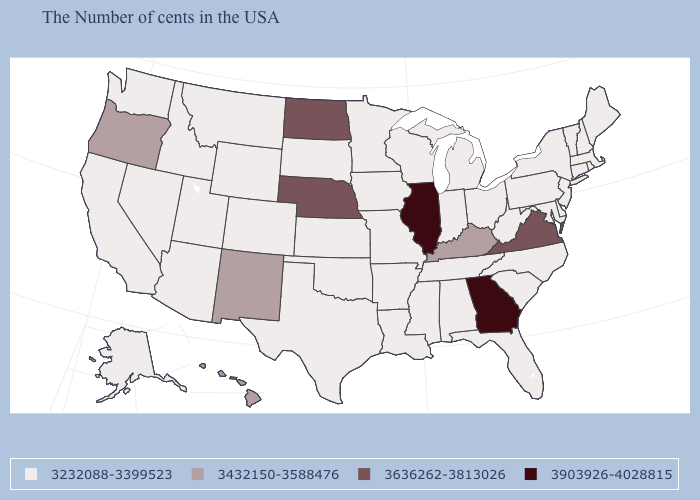Name the states that have a value in the range 3432150-3588476?
Answer briefly. Kentucky, New Mexico, Oregon, Hawaii. What is the value of Iowa?
Concise answer only. 3232088-3399523. Among the states that border Ohio , does Kentucky have the highest value?
Write a very short answer. Yes. What is the value of New Jersey?
Quick response, please. 3232088-3399523. Name the states that have a value in the range 3636262-3813026?
Keep it brief. Virginia, Nebraska, North Dakota. What is the highest value in the USA?
Give a very brief answer. 3903926-4028815. Name the states that have a value in the range 3232088-3399523?
Short answer required. Maine, Massachusetts, Rhode Island, New Hampshire, Vermont, Connecticut, New York, New Jersey, Delaware, Maryland, Pennsylvania, North Carolina, South Carolina, West Virginia, Ohio, Florida, Michigan, Indiana, Alabama, Tennessee, Wisconsin, Mississippi, Louisiana, Missouri, Arkansas, Minnesota, Iowa, Kansas, Oklahoma, Texas, South Dakota, Wyoming, Colorado, Utah, Montana, Arizona, Idaho, Nevada, California, Washington, Alaska. Does the map have missing data?
Answer briefly. No. Does New York have the same value as Illinois?
Give a very brief answer. No. Which states have the lowest value in the USA?
Give a very brief answer. Maine, Massachusetts, Rhode Island, New Hampshire, Vermont, Connecticut, New York, New Jersey, Delaware, Maryland, Pennsylvania, North Carolina, South Carolina, West Virginia, Ohio, Florida, Michigan, Indiana, Alabama, Tennessee, Wisconsin, Mississippi, Louisiana, Missouri, Arkansas, Minnesota, Iowa, Kansas, Oklahoma, Texas, South Dakota, Wyoming, Colorado, Utah, Montana, Arizona, Idaho, Nevada, California, Washington, Alaska. Does Wisconsin have the lowest value in the MidWest?
Quick response, please. Yes. Does Oklahoma have the lowest value in the USA?
Write a very short answer. Yes. 